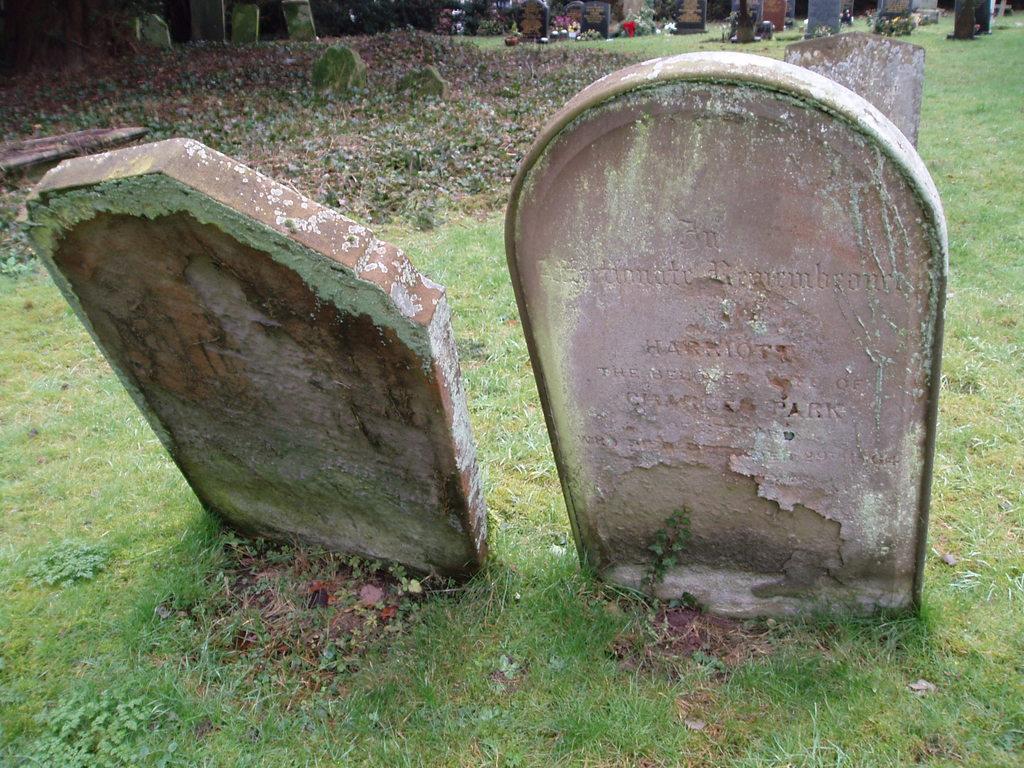In one or two sentences, can you explain what this image depicts? In this picture there are two head stones on a greenery ground and there are few other head stones in the background. 